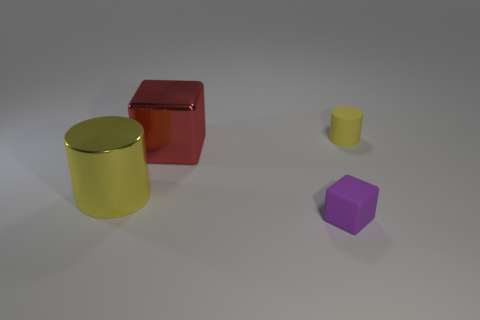Is there any other thing that has the same size as the purple object?
Your answer should be compact. Yes. Do the shiny cube and the tiny matte object that is in front of the big red metal thing have the same color?
Your response must be concise. No. Is the number of big cubes that are right of the purple matte cube the same as the number of tiny yellow objects behind the small yellow rubber object?
Your answer should be compact. Yes. What material is the small object to the left of the rubber cylinder?
Offer a very short reply. Rubber. How many things are either cylinders in front of the red metal thing or large gray rubber cubes?
Ensure brevity in your answer.  1. How many other objects are there of the same shape as the purple thing?
Offer a very short reply. 1. There is a tiny matte thing to the left of the yellow rubber thing; does it have the same shape as the tiny yellow rubber object?
Ensure brevity in your answer.  No. There is a small cylinder; are there any large red metal blocks behind it?
Offer a very short reply. No. What number of large things are either yellow shiny cylinders or balls?
Your answer should be very brief. 1. Do the big red object and the purple object have the same material?
Give a very brief answer. No. 